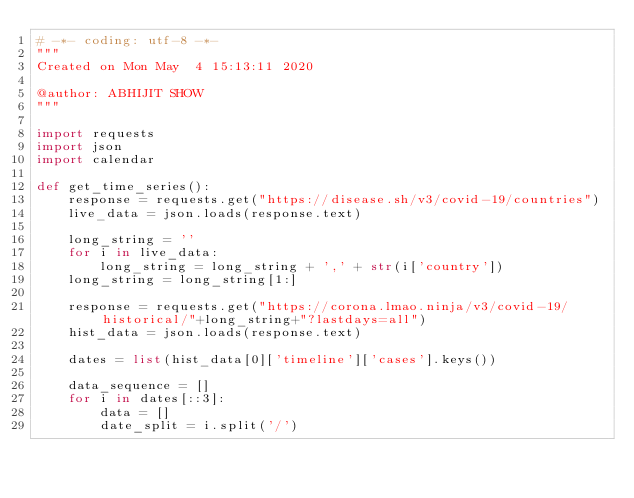Convert code to text. <code><loc_0><loc_0><loc_500><loc_500><_Python_># -*- coding: utf-8 -*-
"""
Created on Mon May  4 15:13:11 2020

@author: ABHIJIT SHOW
"""

import requests
import json
import calendar

def get_time_series():
    response = requests.get("https://disease.sh/v3/covid-19/countries")
    live_data = json.loads(response.text)
    
    long_string = ''
    for i in live_data:
        long_string = long_string + ',' + str(i['country'])
    long_string = long_string[1:]
    
    response = requests.get("https://corona.lmao.ninja/v3/covid-19/historical/"+long_string+"?lastdays=all")
    hist_data = json.loads(response.text)
    
    dates = list(hist_data[0]['timeline']['cases'].keys())
    
    data_sequence = []
    for i in dates[::3]:
        data = []
        date_split = i.split('/')</code> 